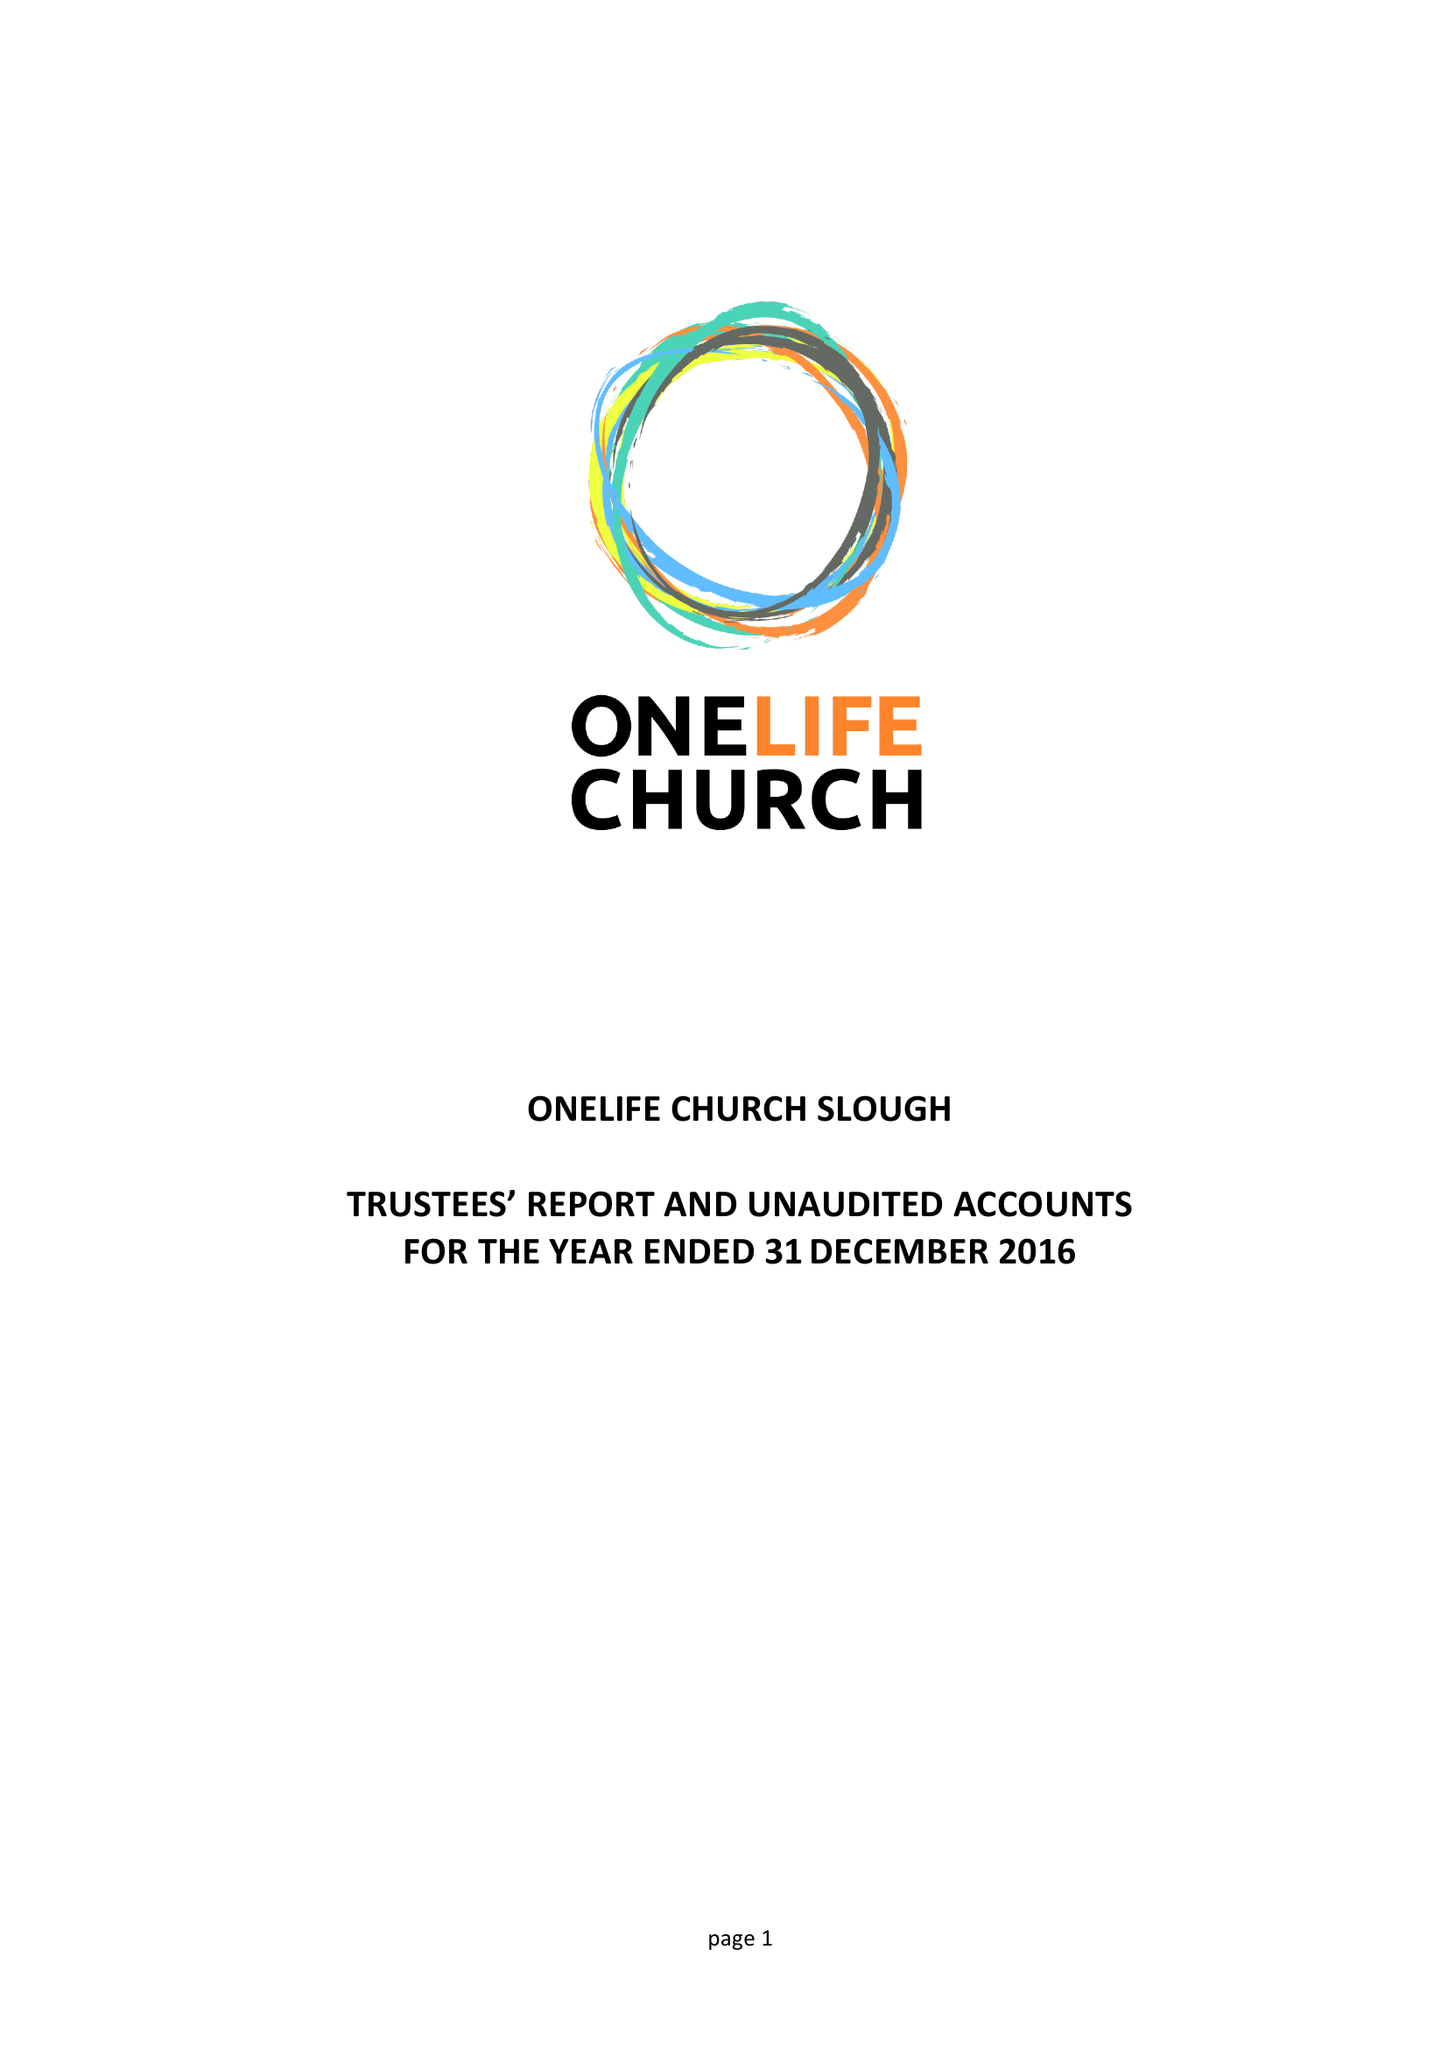What is the value for the address__street_line?
Answer the question using a single word or phrase. 306 SCAFELL ROAD 